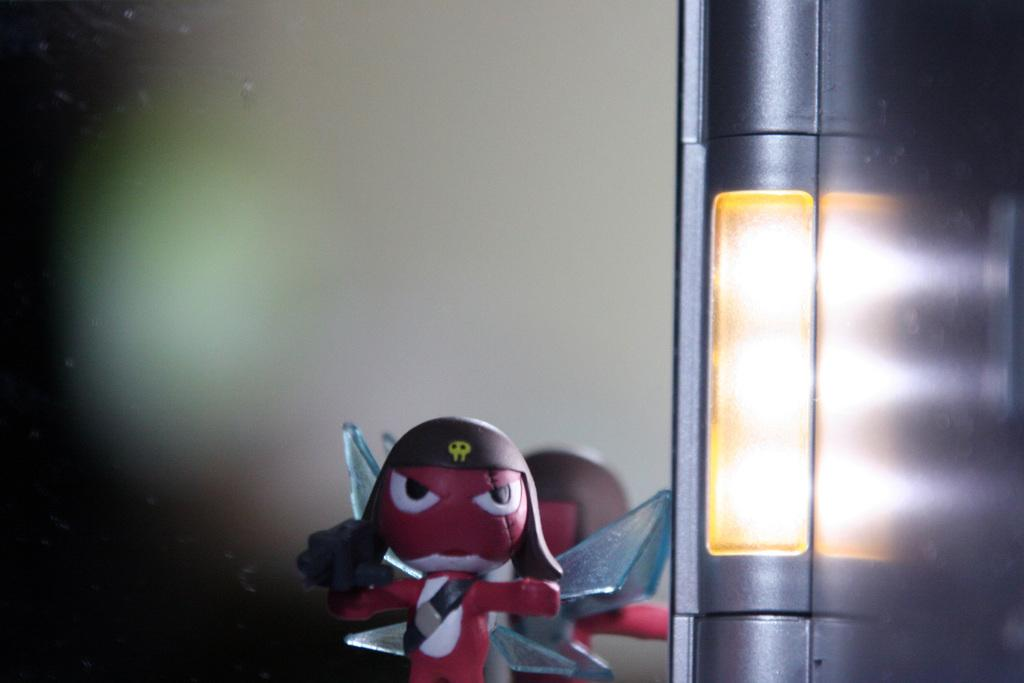What is the main object in the foreground of the image? There is a toy in the foreground of the image. What can be seen on the right side of the image? There is a light and pole on the right side of the image. How would you describe the background of the image? The background of the image is blurred. How many crimes are being committed in the image? There is no indication of any crime being committed in the image. What type of meat is being grilled in the image? There is no meat or grill present in the image. 